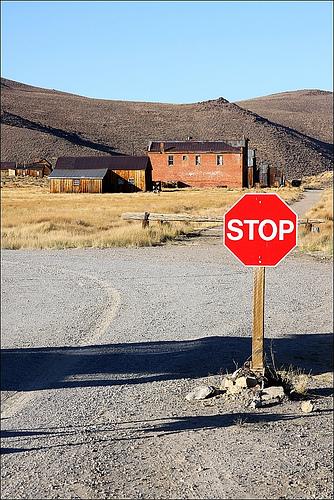Is the grass green?
Quick response, please. No. What does the sign say?
Quick response, please. Stop. Is this a straight road?
Write a very short answer. No. 